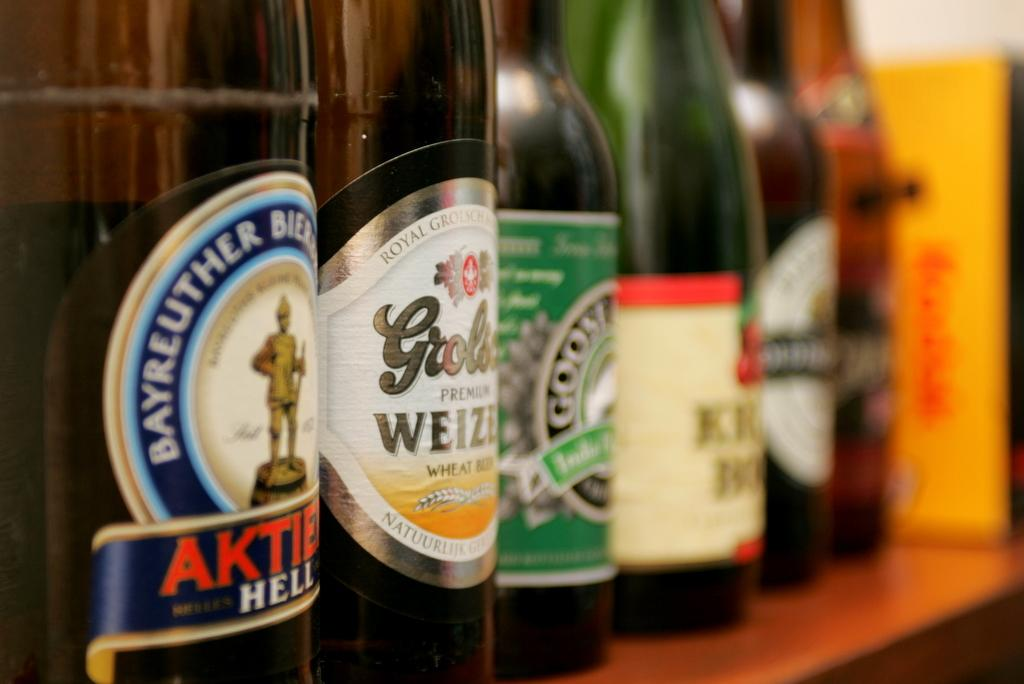<image>
Describe the image concisely. Several labeled drink bottles lined up, including Bayreuther. 